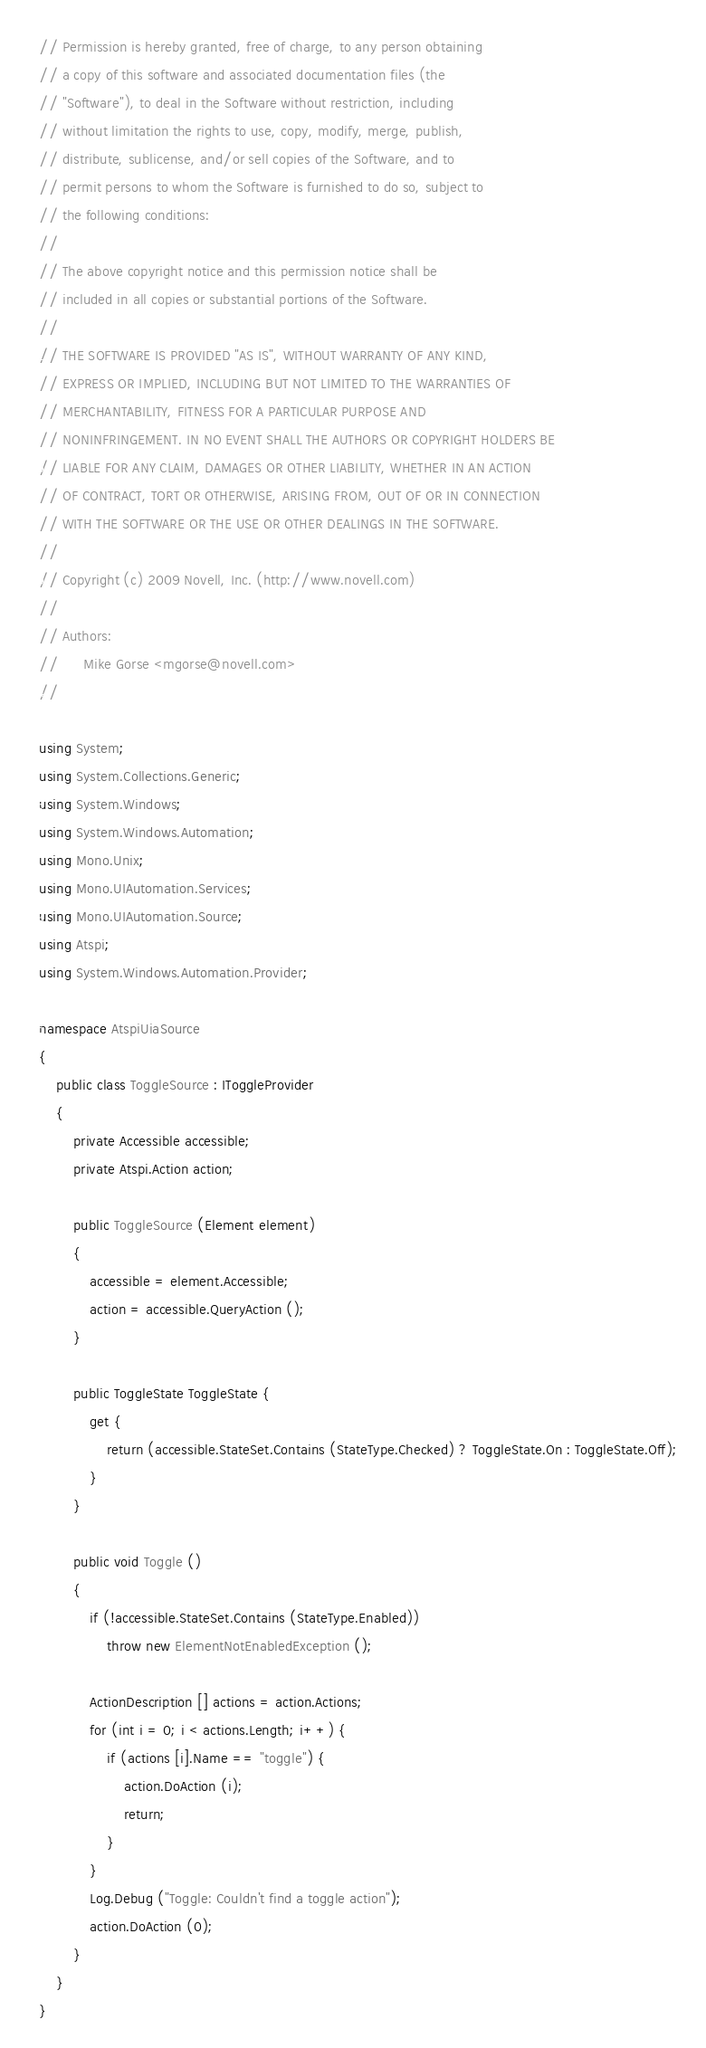<code> <loc_0><loc_0><loc_500><loc_500><_C#_>// Permission is hereby granted, free of charge, to any person obtaining
// a copy of this software and associated documentation files (the
// "Software"), to deal in the Software without restriction, including
// without limitation the rights to use, copy, modify, merge, publish,
// distribute, sublicense, and/or sell copies of the Software, and to
// permit persons to whom the Software is furnished to do so, subject to
// the following conditions:
// 
// The above copyright notice and this permission notice shall be
// included in all copies or substantial portions of the Software.
// 
// THE SOFTWARE IS PROVIDED "AS IS", WITHOUT WARRANTY OF ANY KIND,
// EXPRESS OR IMPLIED, INCLUDING BUT NOT LIMITED TO THE WARRANTIES OF
// MERCHANTABILITY, FITNESS FOR A PARTICULAR PURPOSE AND
// NONINFRINGEMENT. IN NO EVENT SHALL THE AUTHORS OR COPYRIGHT HOLDERS BE
// LIABLE FOR ANY CLAIM, DAMAGES OR OTHER LIABILITY, WHETHER IN AN ACTION
// OF CONTRACT, TORT OR OTHERWISE, ARISING FROM, OUT OF OR IN CONNECTION
// WITH THE SOFTWARE OR THE USE OR OTHER DEALINGS IN THE SOFTWARE.
//
// Copyright (c) 2009 Novell, Inc. (http://www.novell.com)
//
// Authors:
//      Mike Gorse <mgorse@novell.com>
//

using System;
using System.Collections.Generic;
using System.Windows;
using System.Windows.Automation;
using Mono.Unix;
using Mono.UIAutomation.Services;
using Mono.UIAutomation.Source;
using Atspi;
using System.Windows.Automation.Provider;

namespace AtspiUiaSource
{
	public class ToggleSource : IToggleProvider
	{
		private Accessible accessible;
		private Atspi.Action action;

		public ToggleSource (Element element)
		{
			accessible = element.Accessible;
			action = accessible.QueryAction ();
		}

		public ToggleState ToggleState {
			get {
				return (accessible.StateSet.Contains (StateType.Checked) ? ToggleState.On : ToggleState.Off);
			}
		}

		public void Toggle ()
		{
			if (!accessible.StateSet.Contains (StateType.Enabled))
				throw new ElementNotEnabledException ();

			ActionDescription [] actions = action.Actions;
			for (int i = 0; i < actions.Length; i++) {
				if (actions [i].Name == "toggle") {
					action.DoAction (i);
					return;
				}
			}
			Log.Debug ("Toggle: Couldn't find a toggle action");
			action.DoAction (0);
		}
	}
}
</code> 